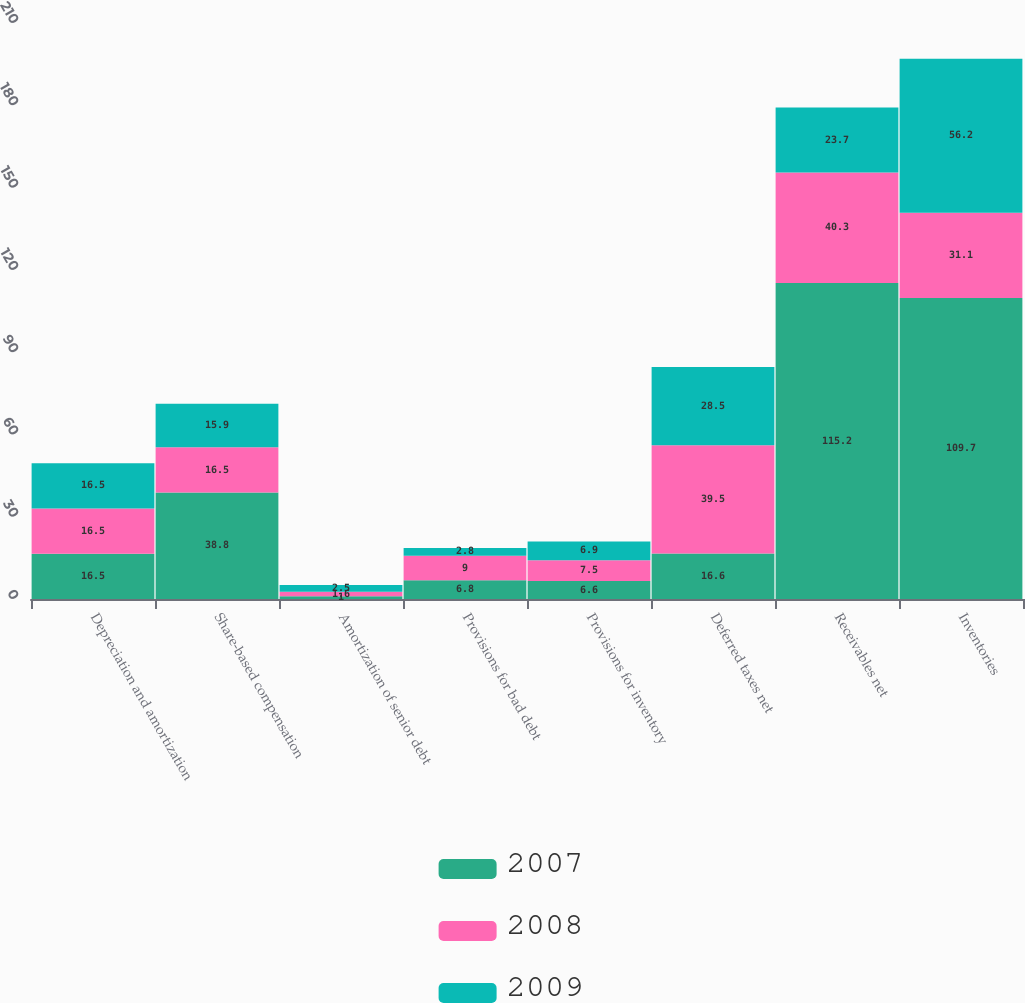Convert chart to OTSL. <chart><loc_0><loc_0><loc_500><loc_500><stacked_bar_chart><ecel><fcel>Depreciation and amortization<fcel>Share-based compensation<fcel>Amortization of senior debt<fcel>Provisions for bad debt<fcel>Provisions for inventory<fcel>Deferred taxes net<fcel>Receivables net<fcel>Inventories<nl><fcel>2007<fcel>16.5<fcel>38.8<fcel>1<fcel>6.8<fcel>6.6<fcel>16.6<fcel>115.2<fcel>109.7<nl><fcel>2008<fcel>16.5<fcel>16.5<fcel>1.6<fcel>9<fcel>7.5<fcel>39.5<fcel>40.3<fcel>31.1<nl><fcel>2009<fcel>16.5<fcel>15.9<fcel>2.5<fcel>2.8<fcel>6.9<fcel>28.5<fcel>23.7<fcel>56.2<nl></chart> 